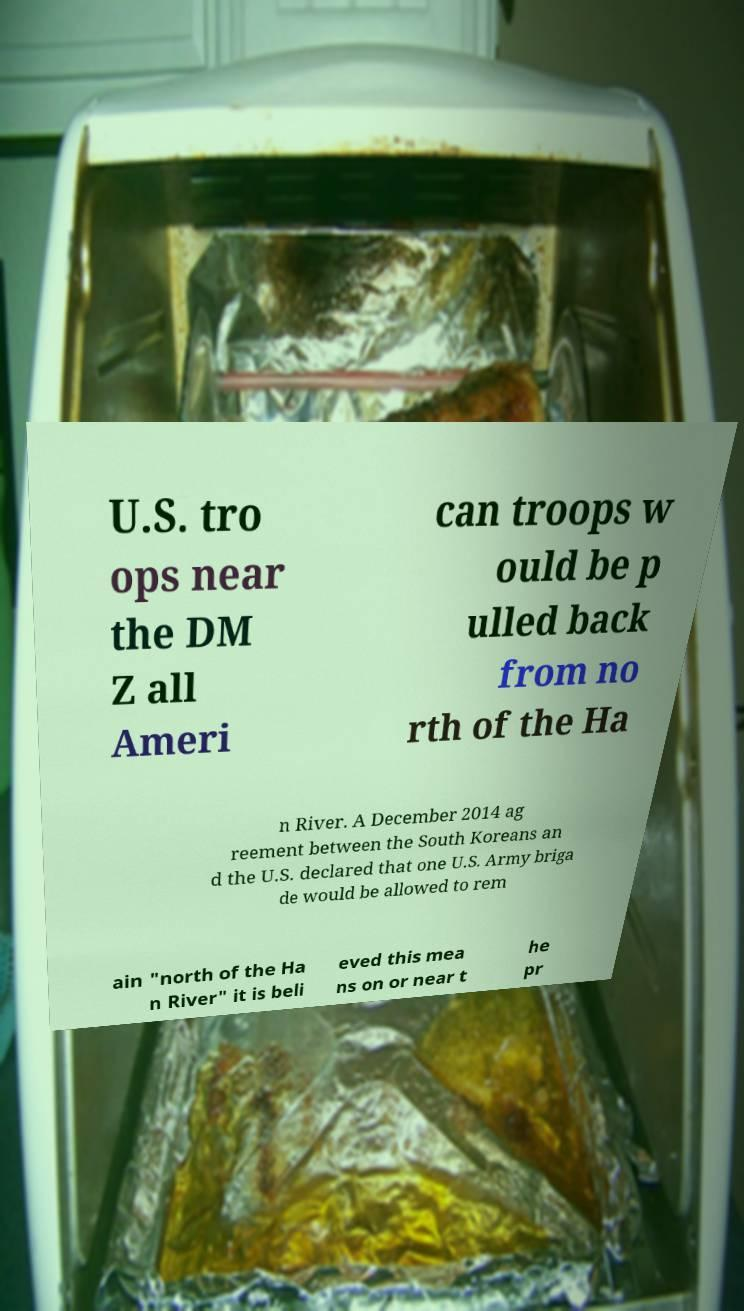Can you accurately transcribe the text from the provided image for me? U.S. tro ops near the DM Z all Ameri can troops w ould be p ulled back from no rth of the Ha n River. A December 2014 ag reement between the South Koreans an d the U.S. declared that one U.S. Army briga de would be allowed to rem ain "north of the Ha n River" it is beli eved this mea ns on or near t he pr 